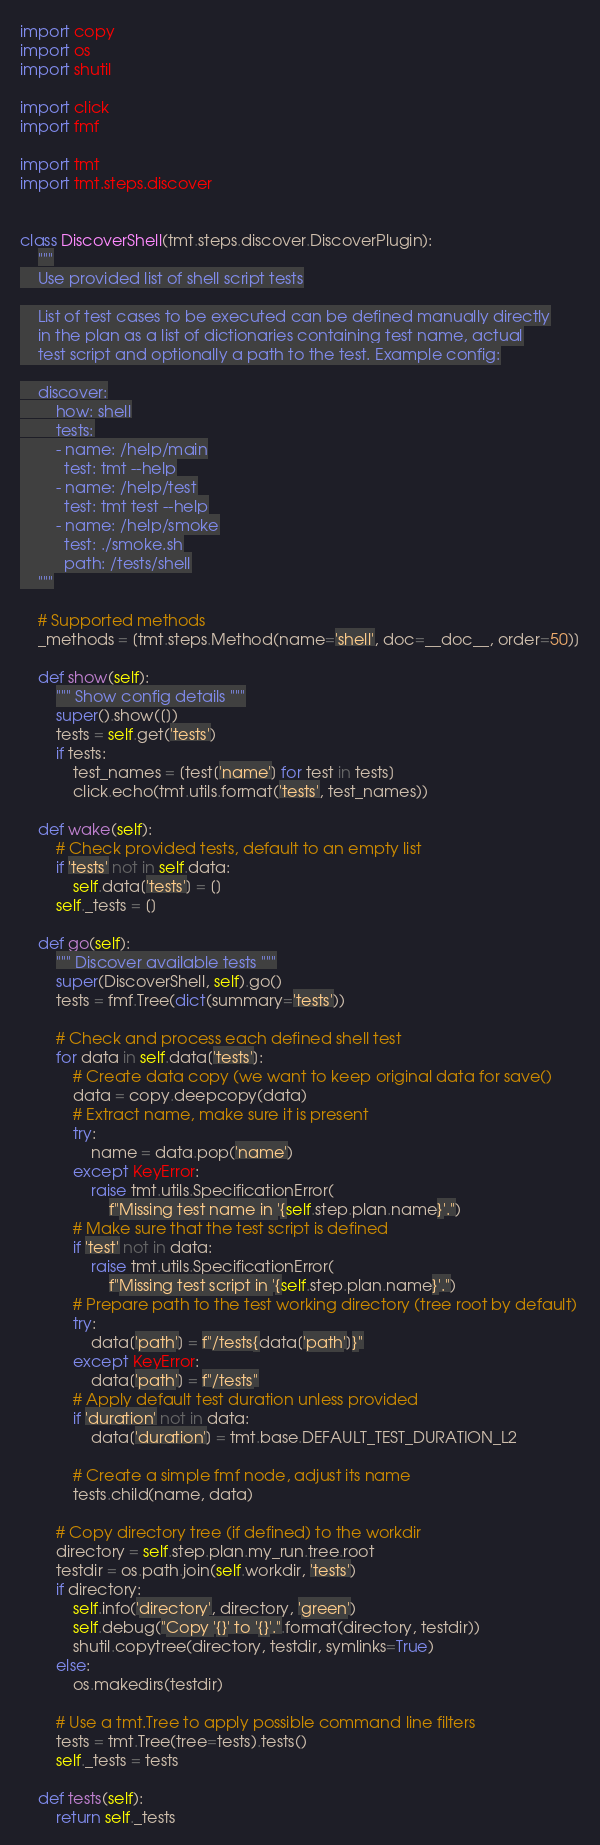Convert code to text. <code><loc_0><loc_0><loc_500><loc_500><_Python_>import copy
import os
import shutil

import click
import fmf

import tmt
import tmt.steps.discover


class DiscoverShell(tmt.steps.discover.DiscoverPlugin):
    """
    Use provided list of shell script tests

    List of test cases to be executed can be defined manually directly
    in the plan as a list of dictionaries containing test name, actual
    test script and optionally a path to the test. Example config:

    discover:
        how: shell
        tests:
        - name: /help/main
          test: tmt --help
        - name: /help/test
          test: tmt test --help
        - name: /help/smoke
          test: ./smoke.sh
          path: /tests/shell
    """

    # Supported methods
    _methods = [tmt.steps.Method(name='shell', doc=__doc__, order=50)]

    def show(self):
        """ Show config details """
        super().show([])
        tests = self.get('tests')
        if tests:
            test_names = [test['name'] for test in tests]
            click.echo(tmt.utils.format('tests', test_names))

    def wake(self):
        # Check provided tests, default to an empty list
        if 'tests' not in self.data:
            self.data['tests'] = []
        self._tests = []

    def go(self):
        """ Discover available tests """
        super(DiscoverShell, self).go()
        tests = fmf.Tree(dict(summary='tests'))

        # Check and process each defined shell test
        for data in self.data['tests']:
            # Create data copy (we want to keep original data for save()
            data = copy.deepcopy(data)
            # Extract name, make sure it is present
            try:
                name = data.pop('name')
            except KeyError:
                raise tmt.utils.SpecificationError(
                    f"Missing test name in '{self.step.plan.name}'.")
            # Make sure that the test script is defined
            if 'test' not in data:
                raise tmt.utils.SpecificationError(
                    f"Missing test script in '{self.step.plan.name}'.")
            # Prepare path to the test working directory (tree root by default)
            try:
                data['path'] = f"/tests{data['path']}"
            except KeyError:
                data['path'] = f"/tests"
            # Apply default test duration unless provided
            if 'duration' not in data:
                data['duration'] = tmt.base.DEFAULT_TEST_DURATION_L2

            # Create a simple fmf node, adjust its name
            tests.child(name, data)

        # Copy directory tree (if defined) to the workdir
        directory = self.step.plan.my_run.tree.root
        testdir = os.path.join(self.workdir, 'tests')
        if directory:
            self.info('directory', directory, 'green')
            self.debug("Copy '{}' to '{}'.".format(directory, testdir))
            shutil.copytree(directory, testdir, symlinks=True)
        else:
            os.makedirs(testdir)

        # Use a tmt.Tree to apply possible command line filters
        tests = tmt.Tree(tree=tests).tests()
        self._tests = tests

    def tests(self):
        return self._tests
</code> 